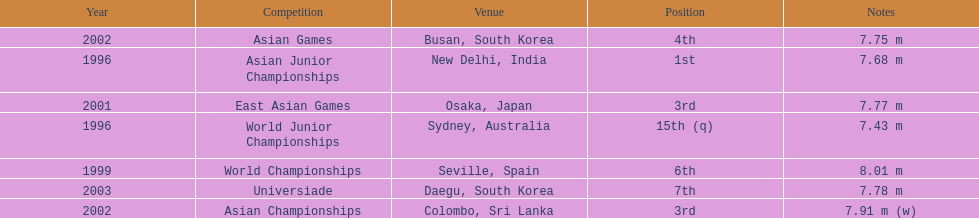In what year was the position of 3rd first achieved? 2001. Could you help me parse every detail presented in this table? {'header': ['Year', 'Competition', 'Venue', 'Position', 'Notes'], 'rows': [['2002', 'Asian Games', 'Busan, South Korea', '4th', '7.75 m'], ['1996', 'Asian Junior Championships', 'New Delhi, India', '1st', '7.68 m'], ['2001', 'East Asian Games', 'Osaka, Japan', '3rd', '7.77 m'], ['1996', 'World Junior Championships', 'Sydney, Australia', '15th (q)', '7.43 m'], ['1999', 'World Championships', 'Seville, Spain', '6th', '8.01 m'], ['2003', 'Universiade', 'Daegu, South Korea', '7th', '7.78 m'], ['2002', 'Asian Championships', 'Colombo, Sri Lanka', '3rd', '7.91 m (w)']]} 